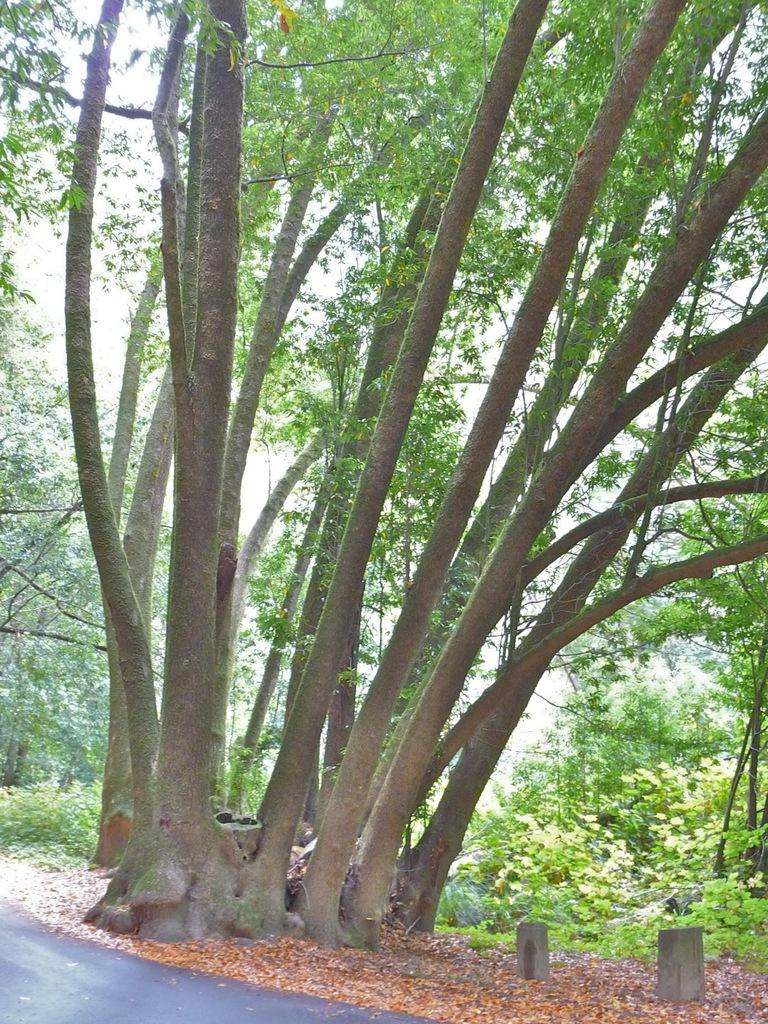What is located at the bottom of the image? There is a road at the bottom of the image. What can be seen in the center of the image? There are trees in the center of the image. What type of jar can be seen filled with flesh in the image? There is no jar or flesh present in the image; it only features a road and trees. 